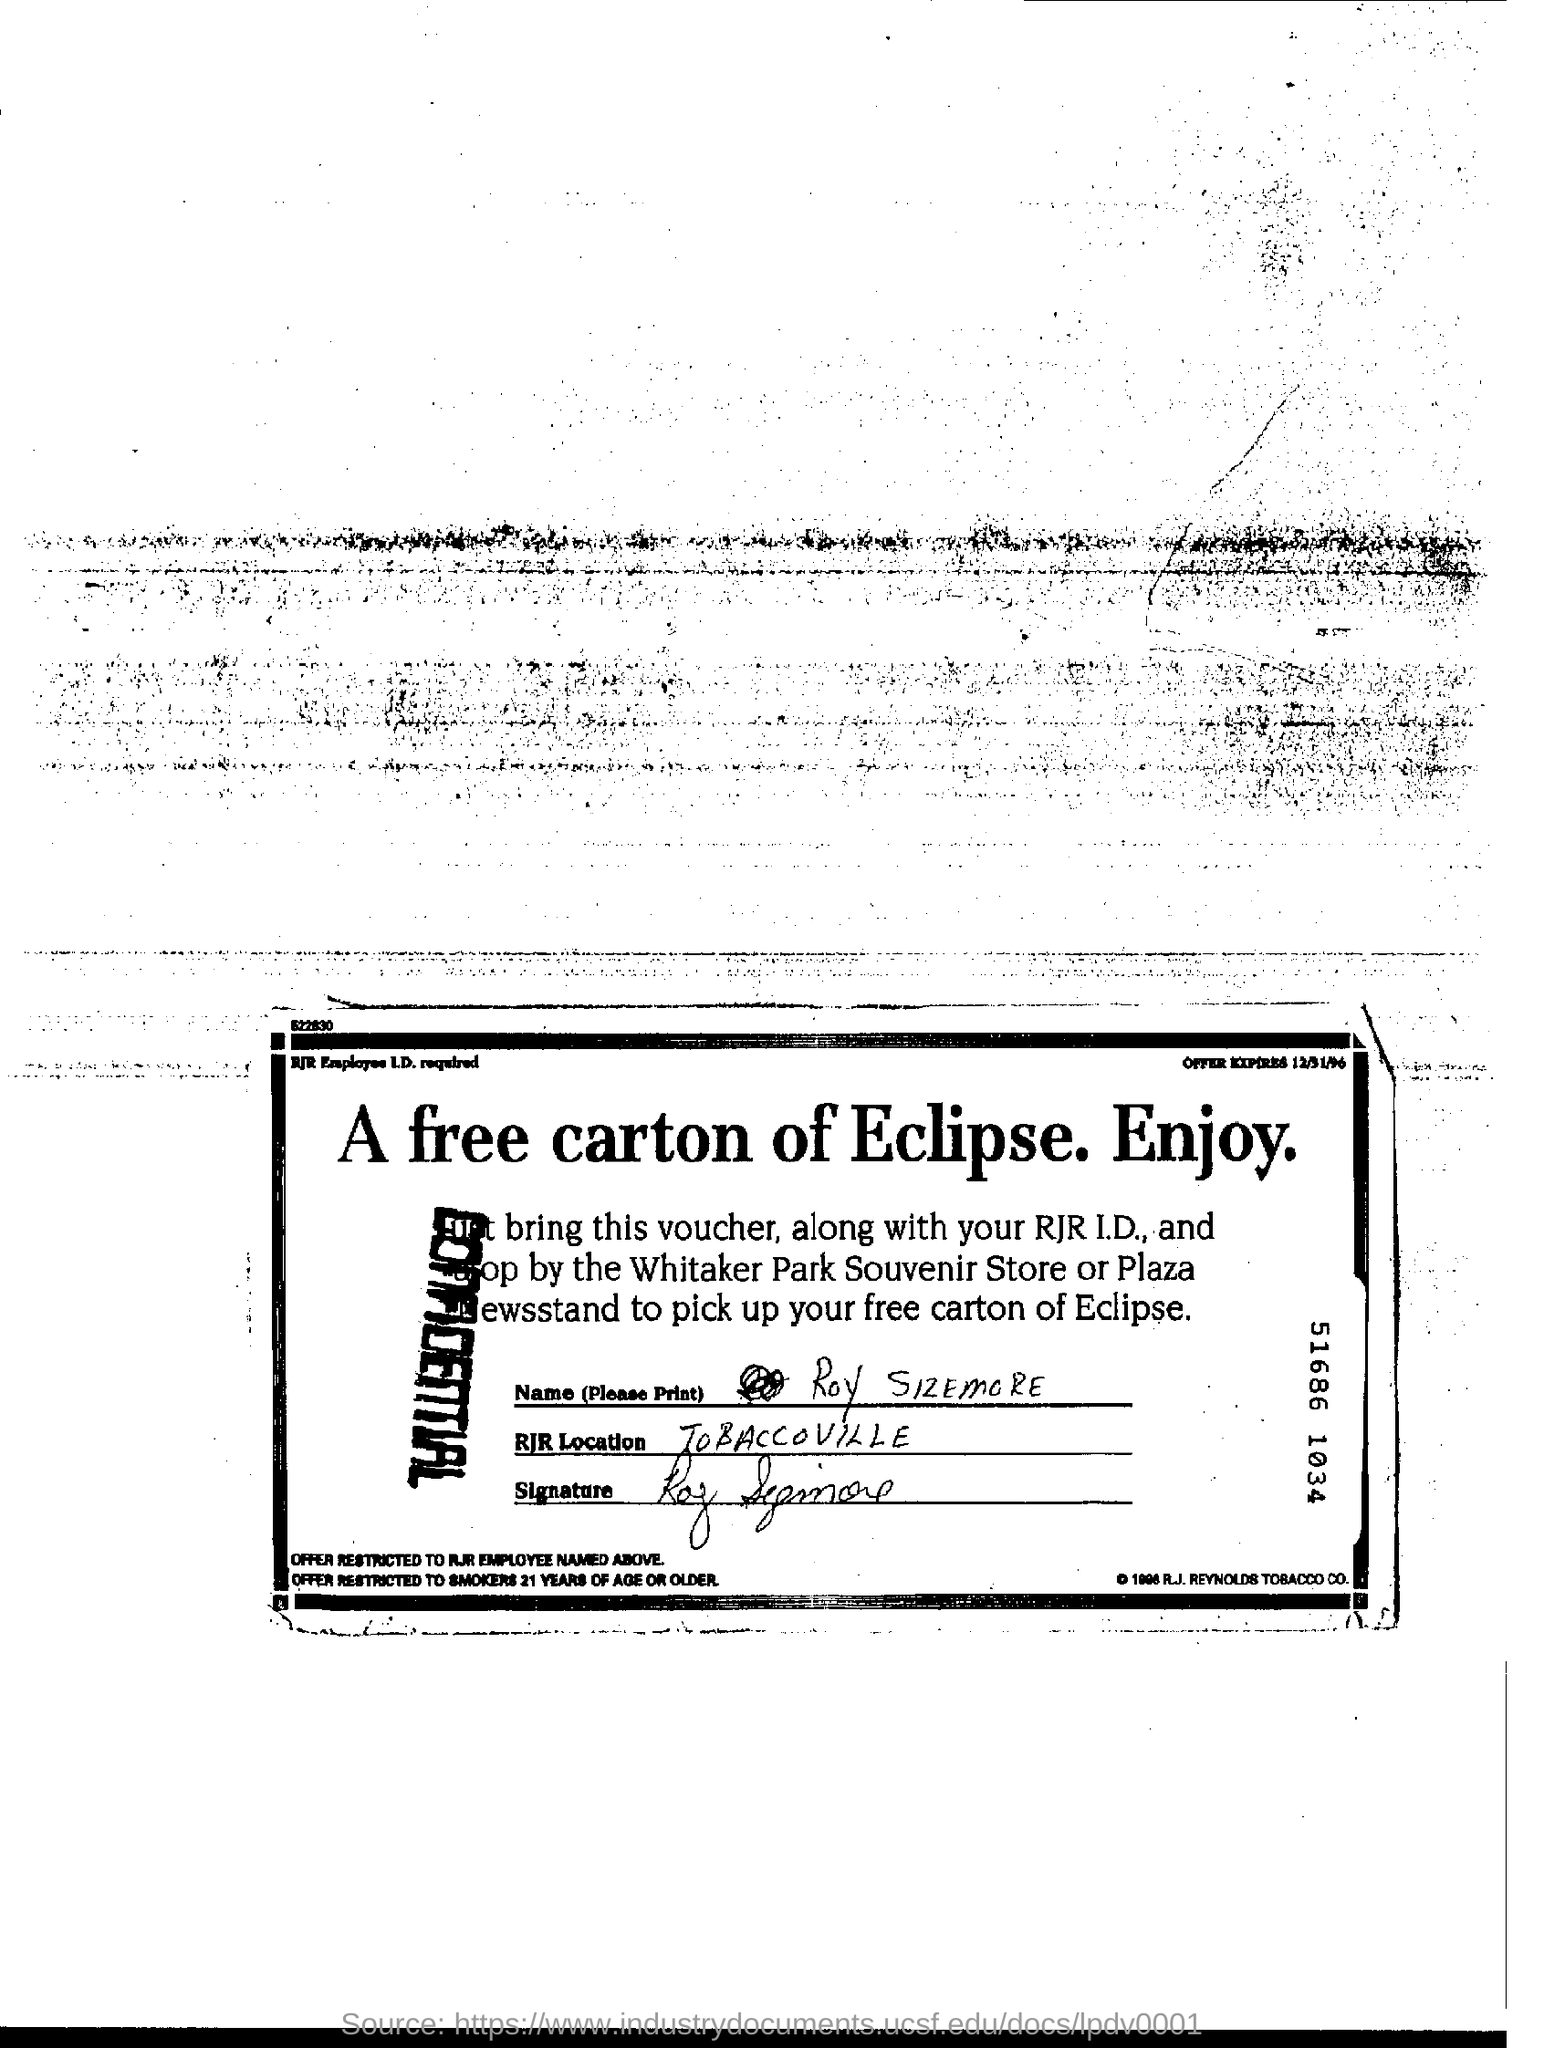What does the stamp across the left side say?
Make the answer very short. CONFIDENTIAL. What is the RJR Location?
Provide a short and direct response. TOBACCOVILLE. Free carton of which cigarette brand is offered?
Provide a succinct answer. Eclipse. 